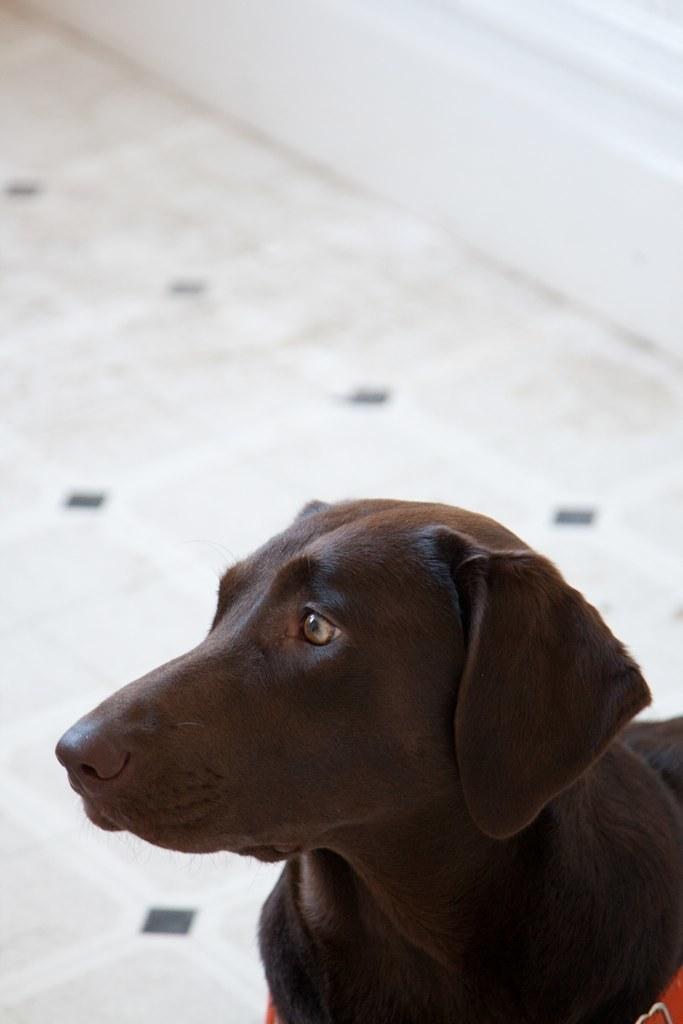Describe this image in one or two sentences. In this picture we can see a dog and blurry background. 